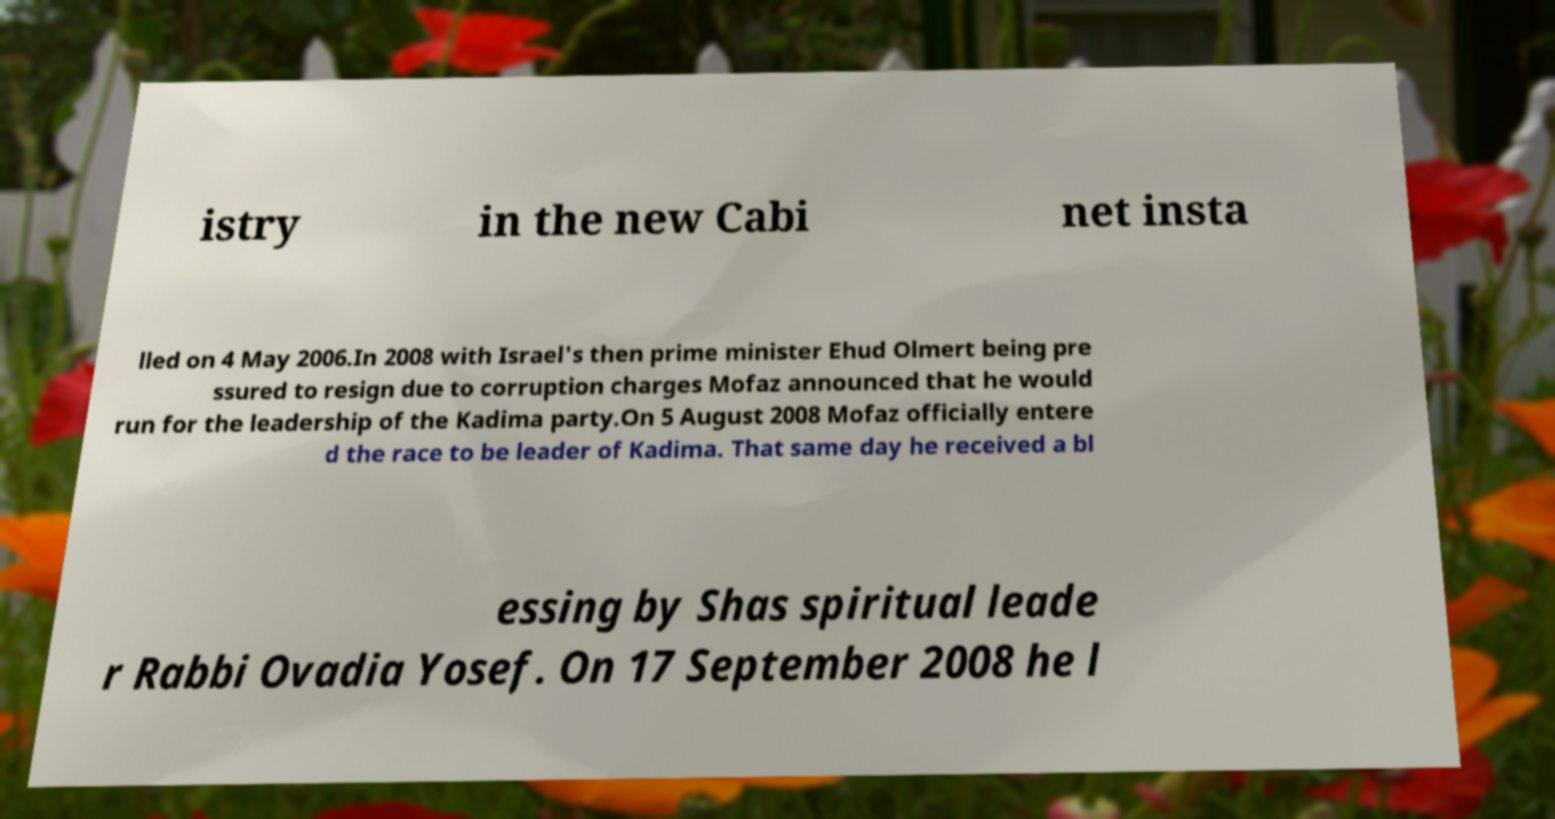Can you accurately transcribe the text from the provided image for me? istry in the new Cabi net insta lled on 4 May 2006.In 2008 with Israel's then prime minister Ehud Olmert being pre ssured to resign due to corruption charges Mofaz announced that he would run for the leadership of the Kadima party.On 5 August 2008 Mofaz officially entere d the race to be leader of Kadima. That same day he received a bl essing by Shas spiritual leade r Rabbi Ovadia Yosef. On 17 September 2008 he l 